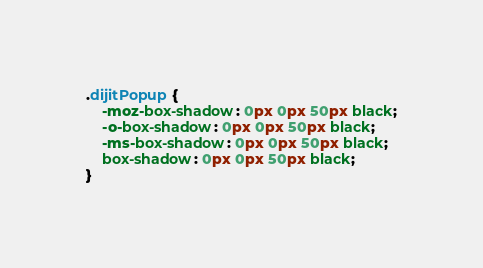Convert code to text. <code><loc_0><loc_0><loc_500><loc_500><_CSS_>
.dijitPopup {
	-moz-box-shadow: 0px 0px 50px black;
	-o-box-shadow: 0px 0px 50px black;
	-ms-box-shadow: 0px 0px 50px black;
	box-shadow: 0px 0px 50px black;
}
</code> 